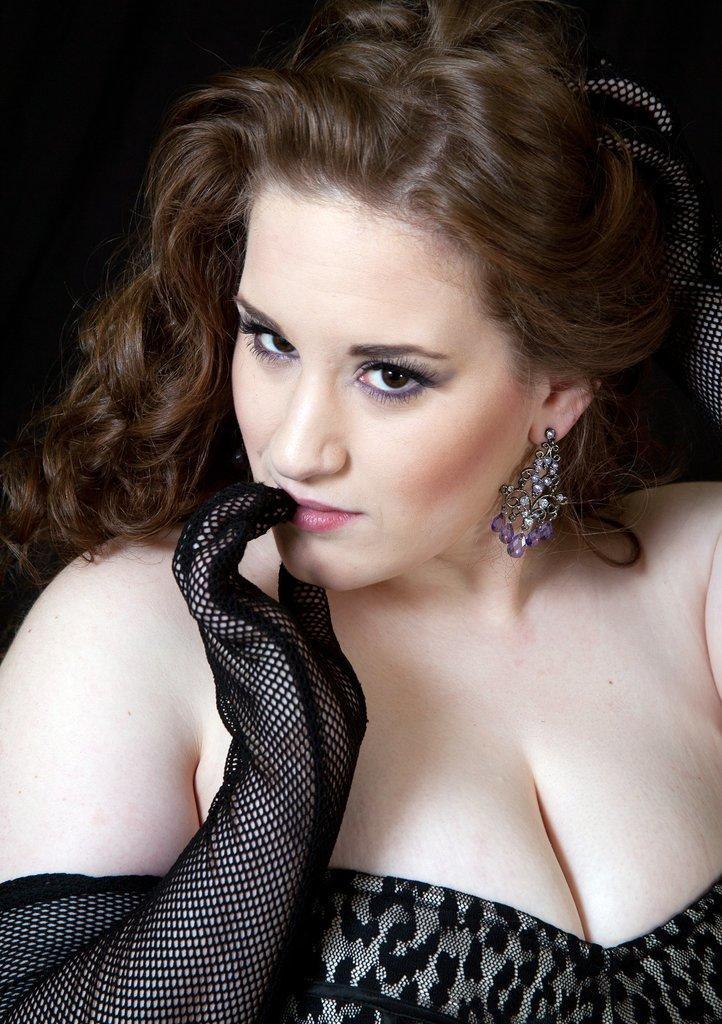Could you give a brief overview of what you see in this image? In the image we can see the close up look of a woman wearing clothes and earrings. The background is blurred. 